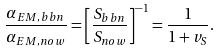<formula> <loc_0><loc_0><loc_500><loc_500>\frac { \alpha _ { E M , b b n } } { \alpha _ { E M , n o w } } = \left [ \frac { S _ { b b n } } { S _ { n o w } } \right ] ^ { - 1 } = \frac { 1 } { 1 + v _ { S } } .</formula> 